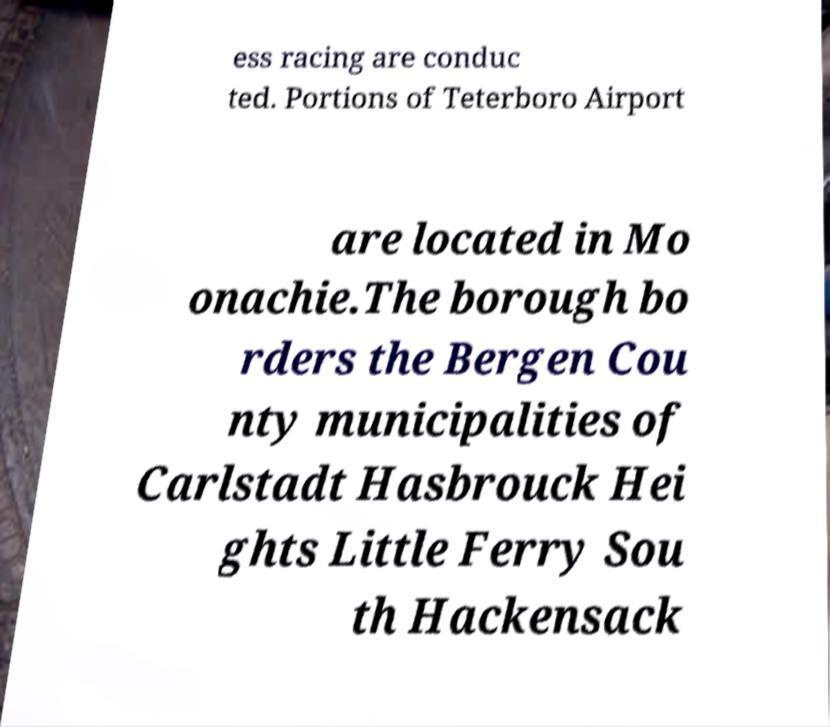For documentation purposes, I need the text within this image transcribed. Could you provide that? ess racing are conduc ted. Portions of Teterboro Airport are located in Mo onachie.The borough bo rders the Bergen Cou nty municipalities of Carlstadt Hasbrouck Hei ghts Little Ferry Sou th Hackensack 